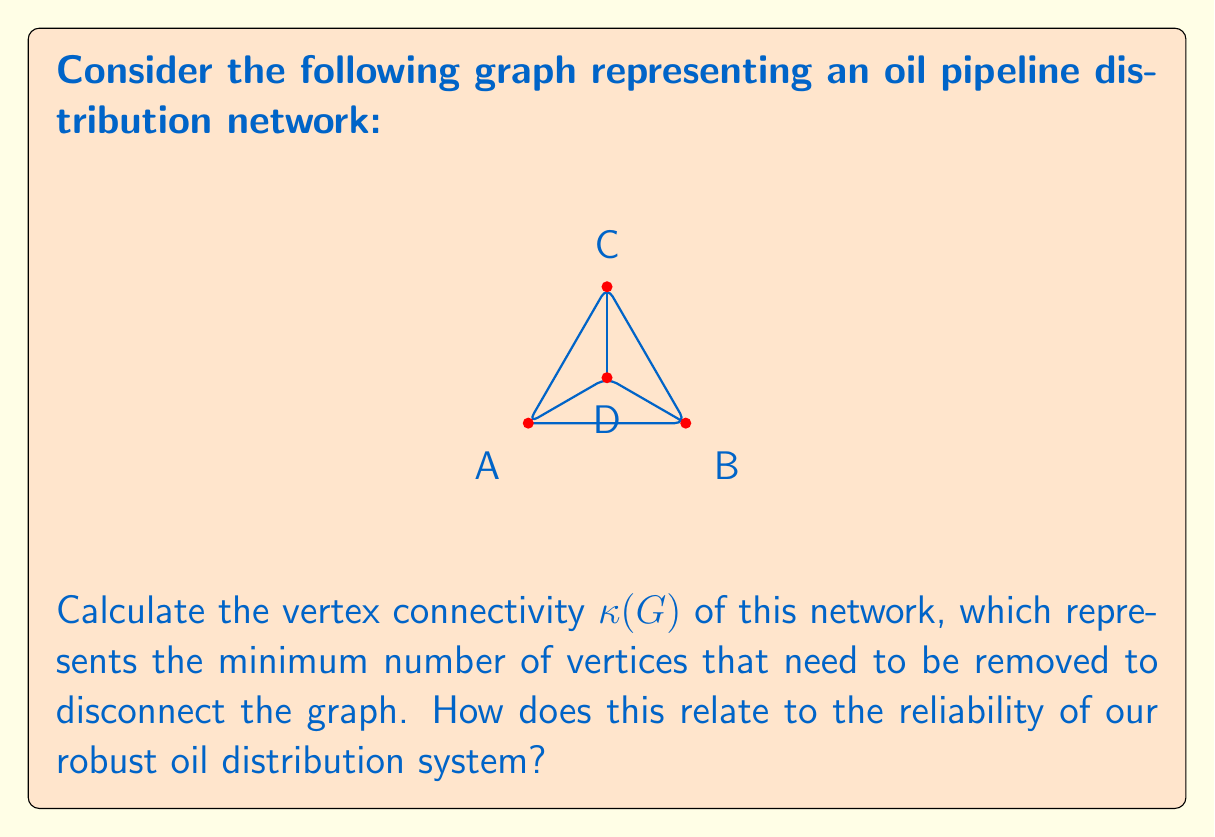Help me with this question. To find the vertex connectivity $\kappa(G)$ of this graph, we need to determine the minimum number of vertices whose removal would disconnect the graph.

Step 1: Analyze the graph structure
- The graph has 4 vertices (A, B, C, D)
- It forms a complete graph K4 with one edge removed (edge AD)

Step 2: Consider possible disconnections
- Removing any single vertex does not disconnect the graph
- Removing any pair of vertices disconnects the graph

Step 3: Determine $\kappa(G)$
- Since removing two vertices is sufficient and necessary to disconnect the graph, we have $\kappa(G) = 2$

Step 4: Interpretation for oil pipeline network
- A higher vertex connectivity indicates a more robust network
- $\kappa(G) = 2$ suggests that our oil distribution system can withstand the failure of any single point without losing overall connectivity
- This demonstrates the resilience of our fossil fuel infrastructure, ensuring consistent energy supply even in case of localized disruptions

The vertex connectivity can be formally defined as:

$$\kappa(G) = \min_{S \subset V} \{|S| : G - S \text{ is disconnected or has only one vertex}\}$$

where $V$ is the set of vertices in graph $G$.
Answer: $\kappa(G) = 2$ 